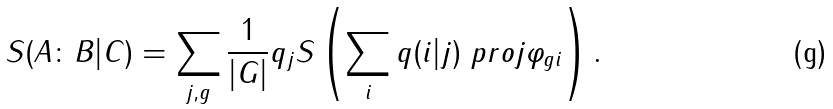Convert formula to latex. <formula><loc_0><loc_0><loc_500><loc_500>S ( A \colon B | C ) = \sum _ { j , g } \frac { 1 } { | G | } q _ { j } S \left ( \sum _ { i } q ( i | j ) \ p r o j { \varphi _ { g i } } \right ) .</formula> 